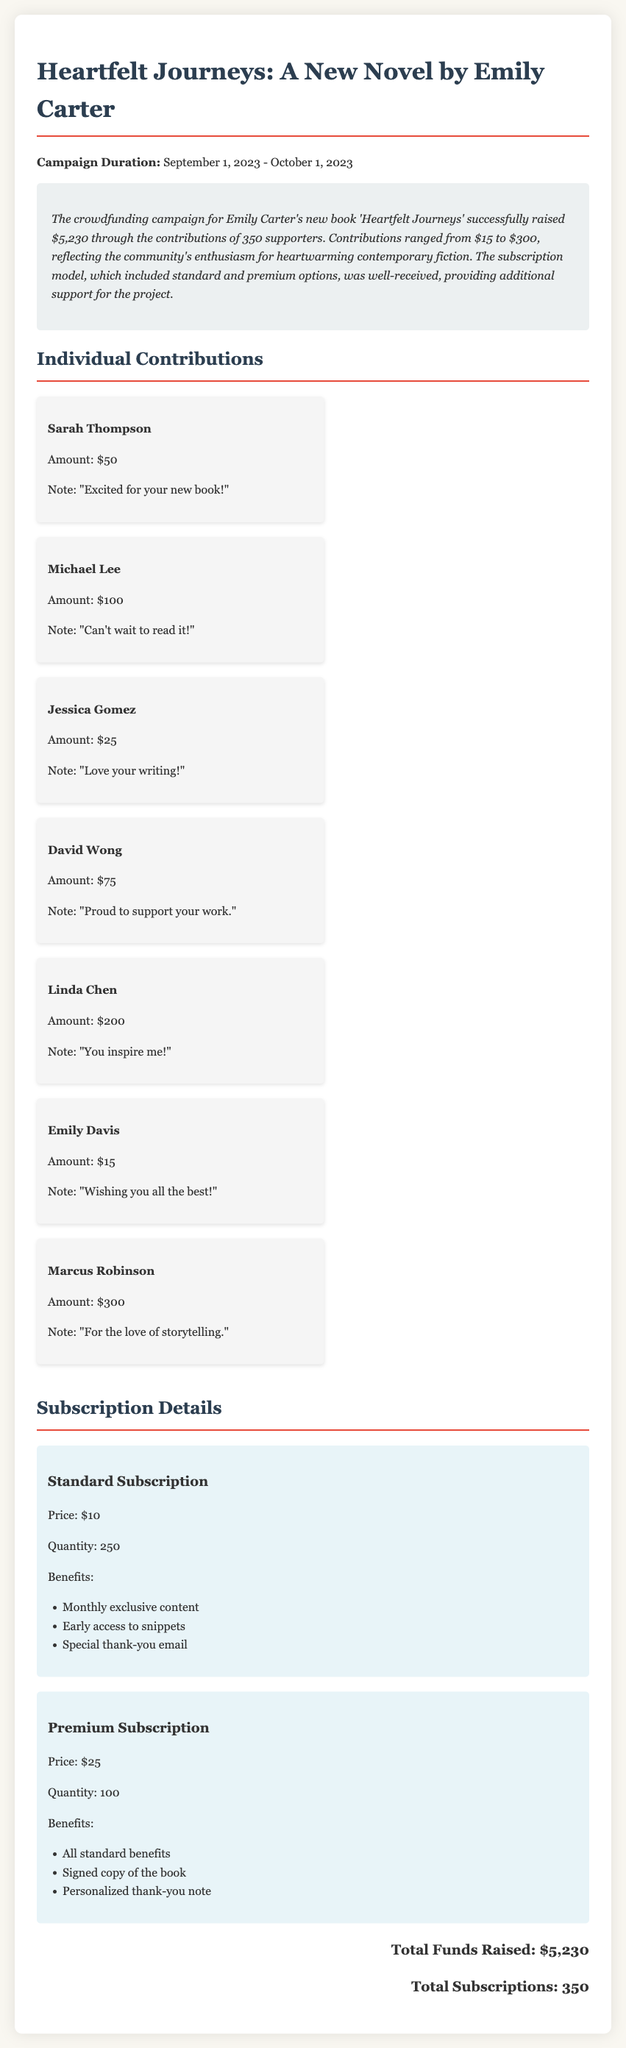what is the total amount raised? The total amount raised through the crowdfunding campaign is stated in the summary of the document.
Answer: $5,230 how many supporters contributed? The document indicates the total number of supporters who contributed to the campaign.
Answer: 350 who is the author of the book? The document mentions the name of the author prominently in the title.
Answer: Emily Carter what is the price of the premium subscription? The price of the premium subscription is listed in the subscription details section.
Answer: $25 what was the highest individual contribution? The highest individual contribution is specifically mentioned in the individual contributions section.
Answer: $300 what benefits are included in the standard subscription? The benefits provided under the standard subscription are listed in bullet points.
Answer: Monthly exclusive content, Early access to snippets, Special thank-you email how many standard subscriptions were sold? The quantity of standard subscriptions is provided directly in the subscription details.
Answer: 250 what is the note from Linda Chen? The document includes individual notes associated with contributions.
Answer: "You inspire me!" 